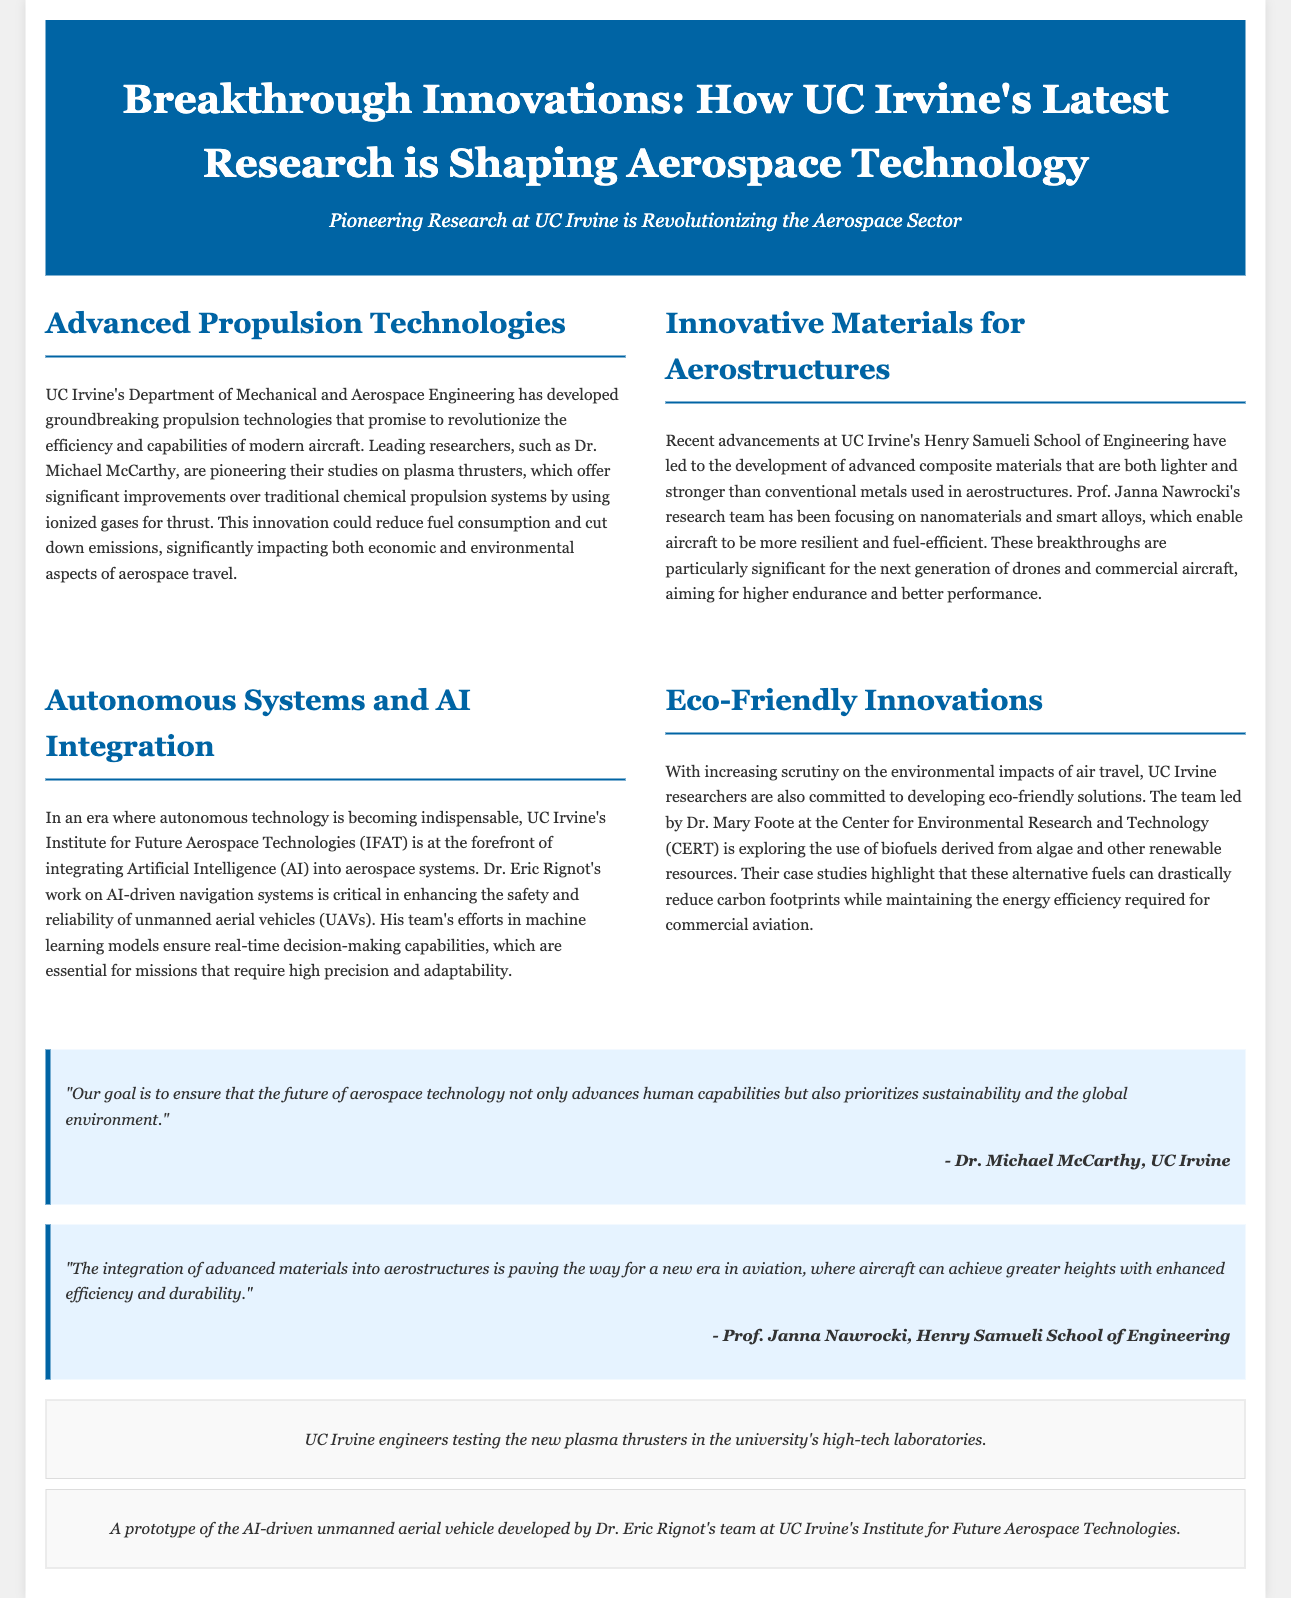What is the main focus of UC Irvine's Department of Mechanical and Aerospace Engineering? The main focus is the development of groundbreaking propulsion technologies.
Answer: Groundbreaking propulsion technologies Who is leading the research team on innovative materials for aerostructures? Prof. Janna Nawrocki is the head of the research team focusing on advanced composite materials.
Answer: Prof. Janna Nawrocki What environmental solution is Dr. Mary Foote's team exploring at UC Irvine? The team is exploring the use of biofuels derived from algae and other renewable resources.
Answer: Biofuels Which technology is being integrated into aerospace systems according to the article? The article mentions the integration of Artificial Intelligence (AI) into aerospace systems.
Answer: Artificial Intelligence (AI) How does UC Irvine's advancement in propulsion technologies impact aerospace travel? The advancements promise to reduce fuel consumption and cut down emissions.
Answer: Reduce fuel consumption and cut down emissions What type of vehicle is Dr. Eric Rignot's team developing? The team is developing an AI-driven unmanned aerial vehicle (UAV).
Answer: AI-driven unmanned aerial vehicle (UAV) What is the overarching goal mentioned by Dr. Michael McCarthy regarding the future of aerospace technology? The goal is to ensure advancements prioritize sustainability and the global environment.
Answer: Sustainability and the global environment 